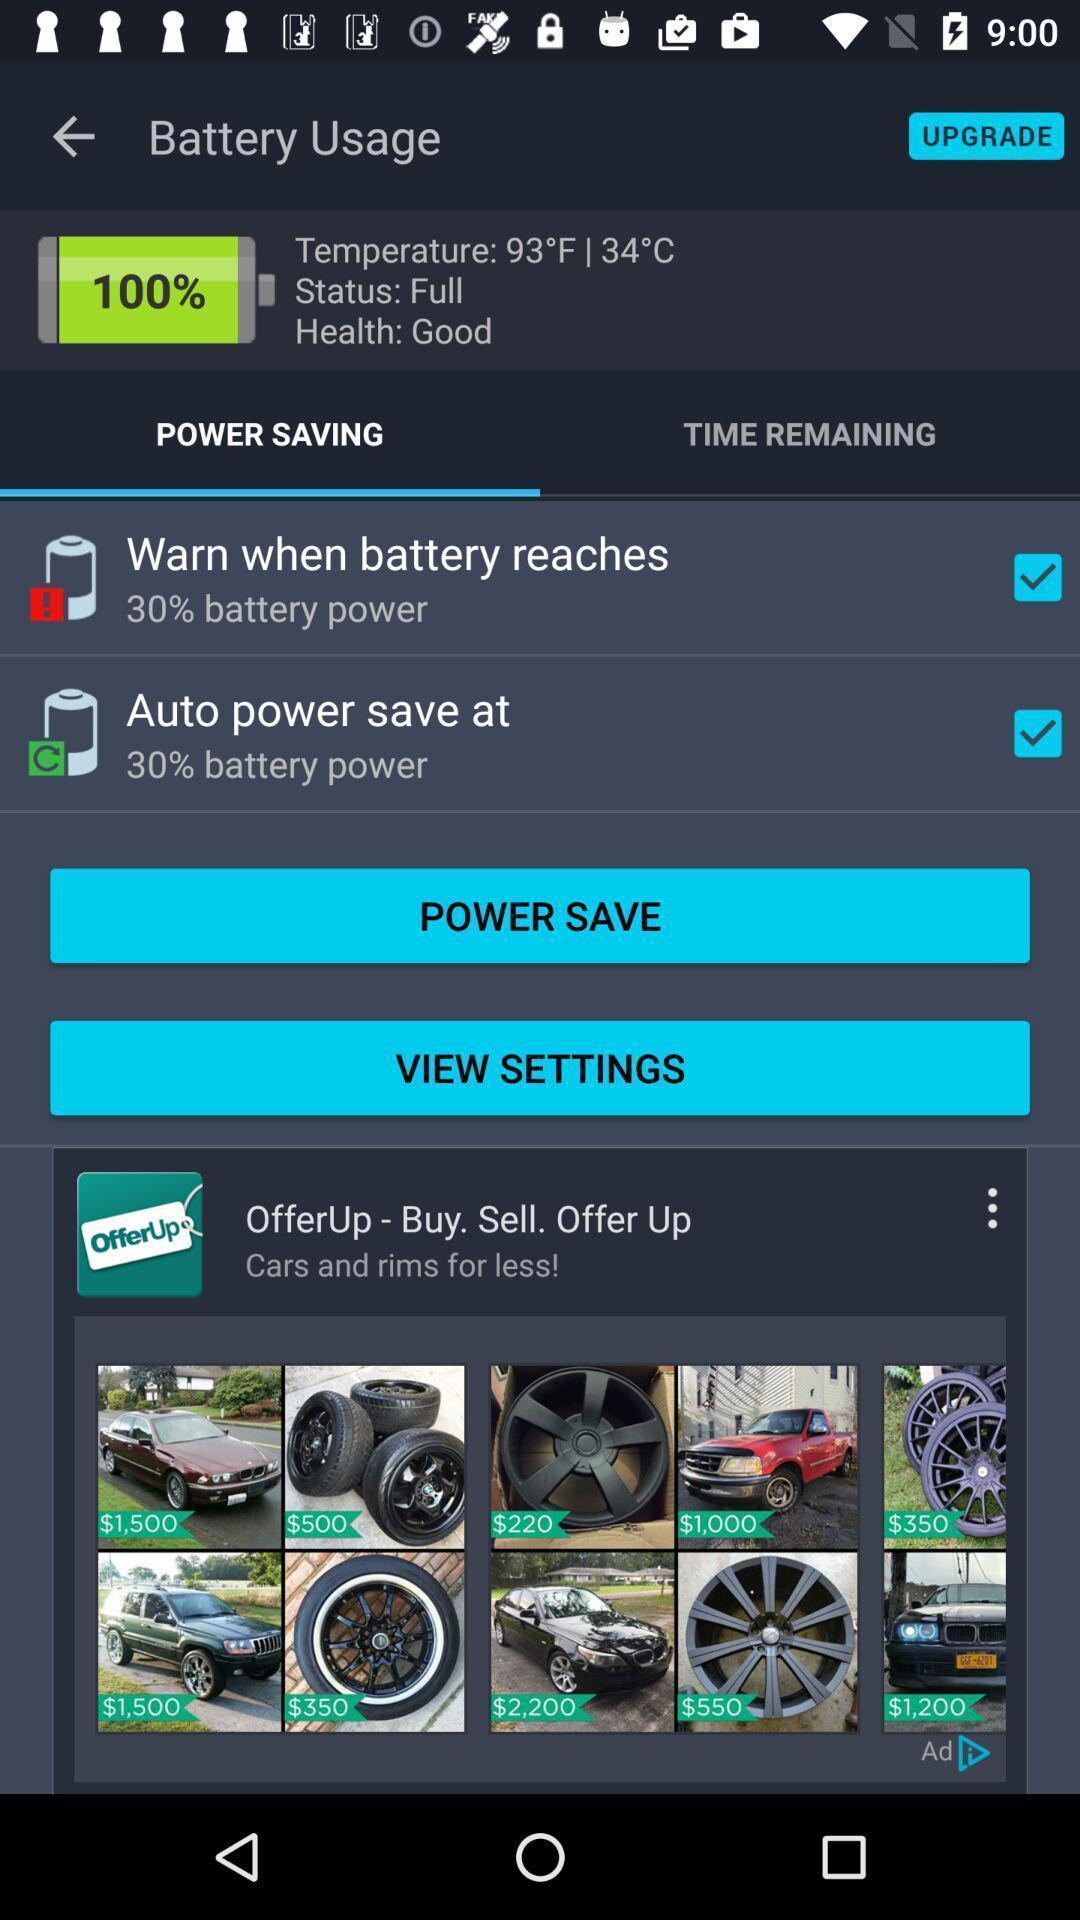Provide a description of this screenshot. Screen showing power saving options. 